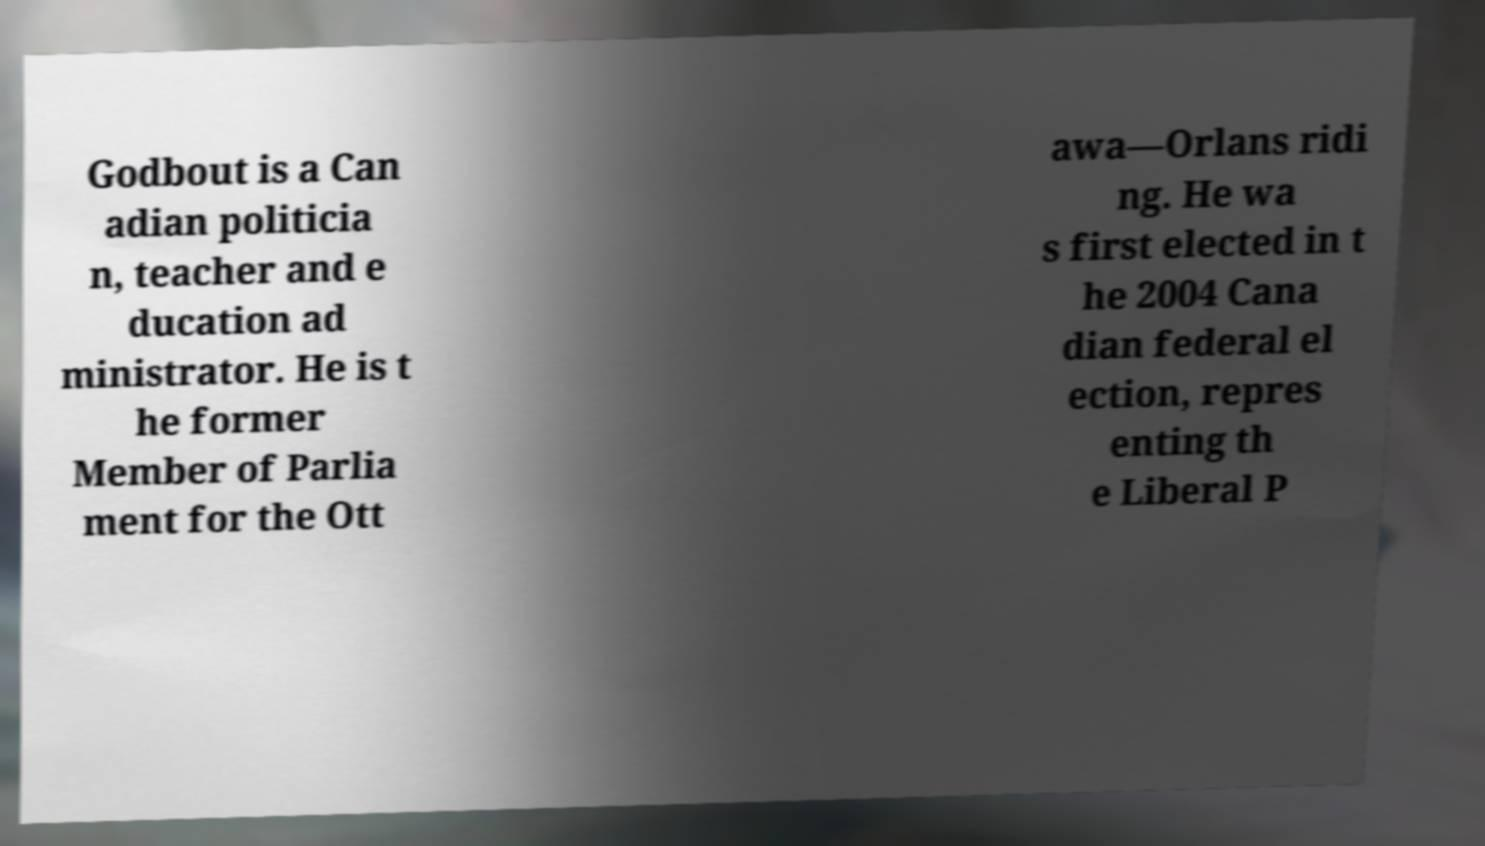For documentation purposes, I need the text within this image transcribed. Could you provide that? Godbout is a Can adian politicia n, teacher and e ducation ad ministrator. He is t he former Member of Parlia ment for the Ott awa—Orlans ridi ng. He wa s first elected in t he 2004 Cana dian federal el ection, repres enting th e Liberal P 